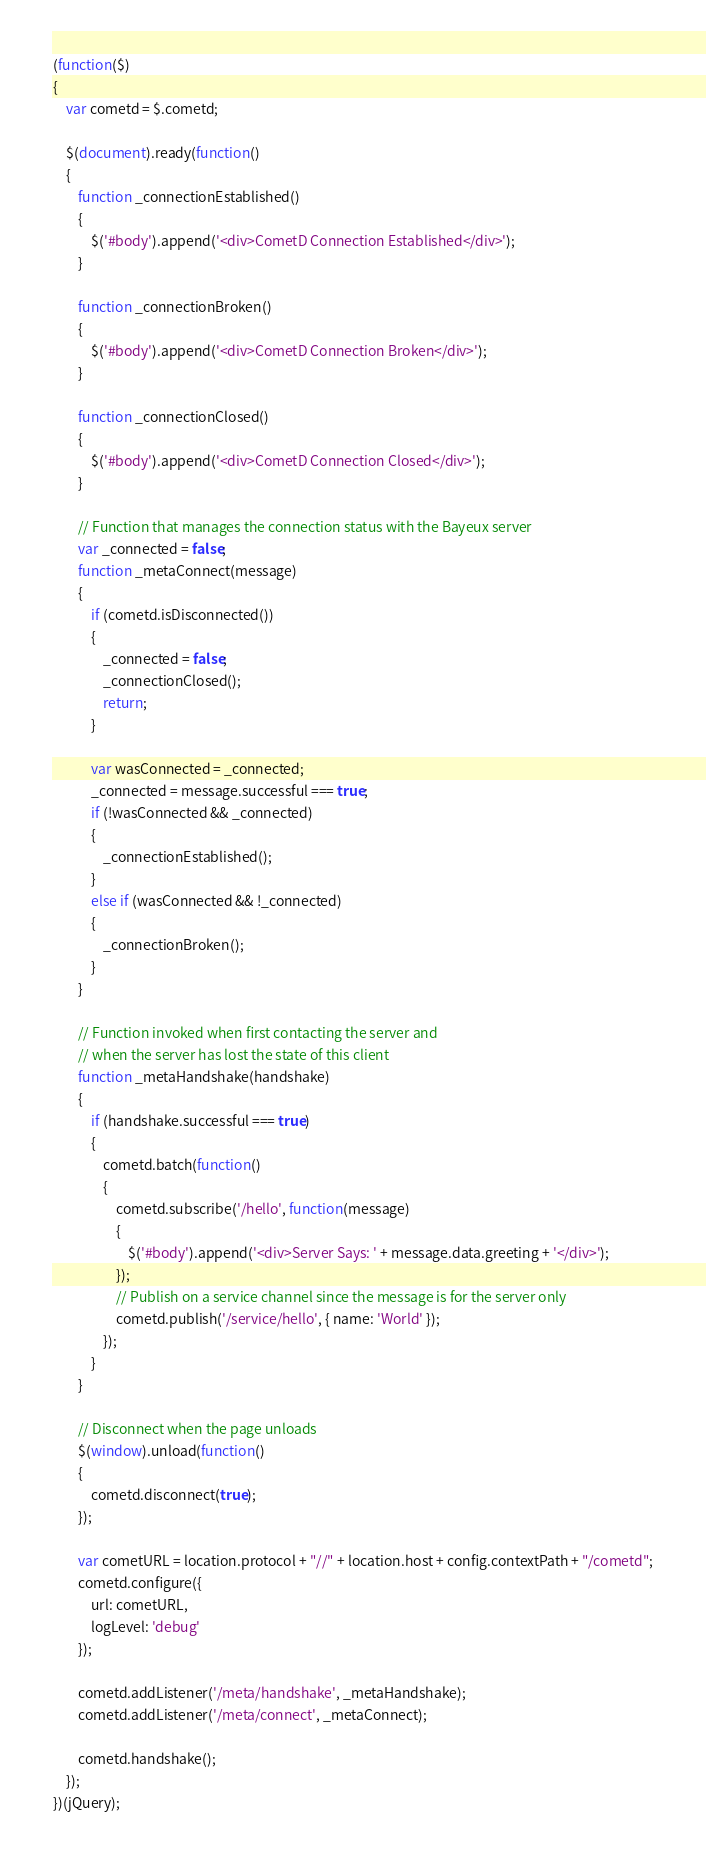Convert code to text. <code><loc_0><loc_0><loc_500><loc_500><_JavaScript_>(function($)
{
    var cometd = $.cometd;

    $(document).ready(function()
    {
        function _connectionEstablished()
        {
            $('#body').append('<div>CometD Connection Established</div>');
        }

        function _connectionBroken()
        {
            $('#body').append('<div>CometD Connection Broken</div>');
        }

        function _connectionClosed()
        {
            $('#body').append('<div>CometD Connection Closed</div>');
        }

        // Function that manages the connection status with the Bayeux server
        var _connected = false;
        function _metaConnect(message)
        {
            if (cometd.isDisconnected())
            {
                _connected = false;
                _connectionClosed();
                return;
            }

            var wasConnected = _connected;
            _connected = message.successful === true;
            if (!wasConnected && _connected)
            {
                _connectionEstablished();
            }
            else if (wasConnected && !_connected)
            {
                _connectionBroken();
            }
        }

        // Function invoked when first contacting the server and
        // when the server has lost the state of this client
        function _metaHandshake(handshake)
        {
            if (handshake.successful === true)
            {
                cometd.batch(function()
                {
                    cometd.subscribe('/hello', function(message)
                    {
                        $('#body').append('<div>Server Says: ' + message.data.greeting + '</div>');
                    });
                    // Publish on a service channel since the message is for the server only
                    cometd.publish('/service/hello', { name: 'World' });
                });
            }
        }

        // Disconnect when the page unloads
        $(window).unload(function()
        {
            cometd.disconnect(true);
        });

        var cometURL = location.protocol + "//" + location.host + config.contextPath + "/cometd";
        cometd.configure({
            url: cometURL,
            logLevel: 'debug'
        });

        cometd.addListener('/meta/handshake', _metaHandshake);
        cometd.addListener('/meta/connect', _metaConnect);

        cometd.handshake();
    });
})(jQuery);
</code> 